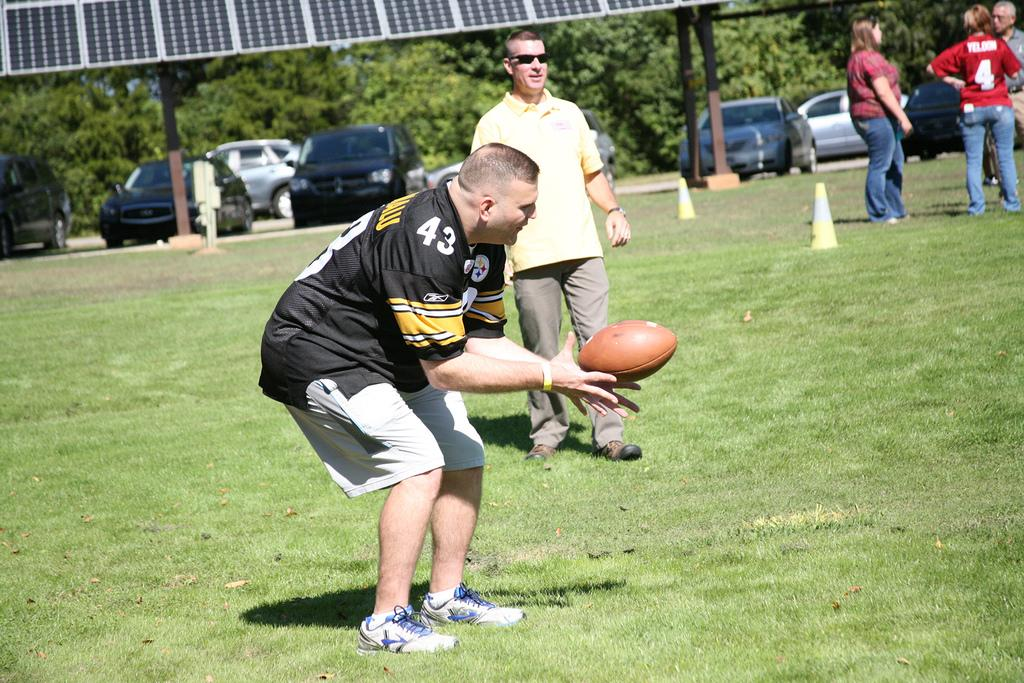<image>
Present a compact description of the photo's key features. a man wearing a number 43 steelers jersey 